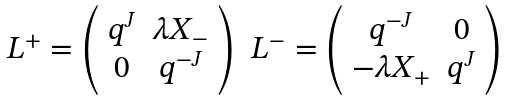Convert formula to latex. <formula><loc_0><loc_0><loc_500><loc_500>\begin{array} { c c } L ^ { + } = \left ( \begin{array} { c c } q ^ { J } & \lambda X _ { - } \\ 0 & q ^ { - J } \end{array} \right ) & L ^ { - } = \left ( \begin{array} { c c } q ^ { - J } & 0 \\ - \lambda X _ { + } & q ^ { J } \end{array} \right ) \end{array}</formula> 